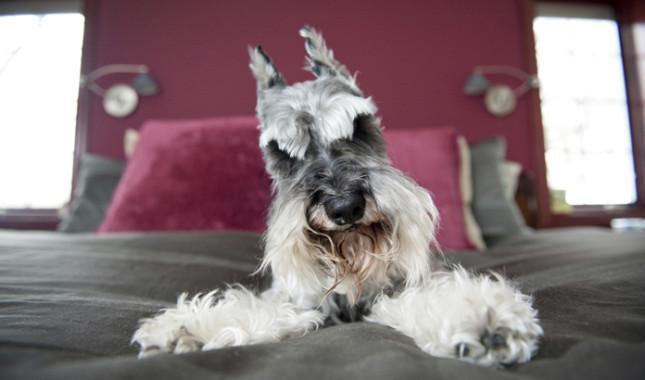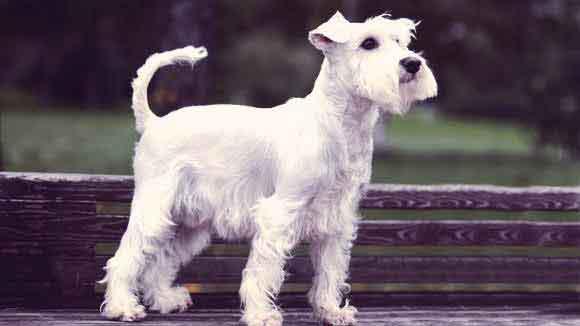The first image is the image on the left, the second image is the image on the right. Given the left and right images, does the statement "One image shows a schnauzer standing and facing toward the right." hold true? Answer yes or no. Yes. 